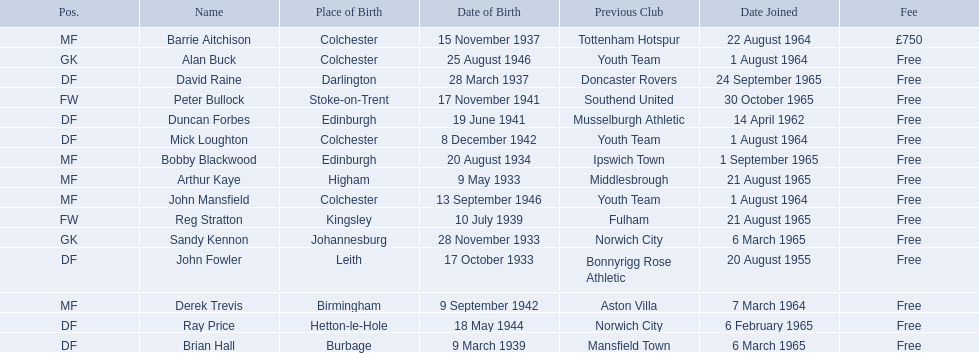When did each player join? 1 August 1964, 6 March 1965, 14 April 1962, 20 August 1955, 6 March 1965, 1 August 1964, 6 February 1965, 24 September 1965, 22 August 1964, 1 September 1965, 21 August 1965, 1 August 1964, 7 March 1964, 30 October 1965, 21 August 1965. And of those, which is the earliest join date? 20 August 1955. Parse the table in full. {'header': ['Pos.', 'Name', 'Place of Birth', 'Date of Birth', 'Previous Club', 'Date Joined', 'Fee'], 'rows': [['MF', 'Barrie Aitchison', 'Colchester', '15 November 1937', 'Tottenham Hotspur', '22 August 1964', '£750'], ['GK', 'Alan Buck', 'Colchester', '25 August 1946', 'Youth Team', '1 August 1964', 'Free'], ['DF', 'David Raine', 'Darlington', '28 March 1937', 'Doncaster Rovers', '24 September 1965', 'Free'], ['FW', 'Peter Bullock', 'Stoke-on-Trent', '17 November 1941', 'Southend United', '30 October 1965', 'Free'], ['DF', 'Duncan Forbes', 'Edinburgh', '19 June 1941', 'Musselburgh Athletic', '14 April 1962', 'Free'], ['DF', 'Mick Loughton', 'Colchester', '8 December 1942', 'Youth Team', '1 August 1964', 'Free'], ['MF', 'Bobby Blackwood', 'Edinburgh', '20 August 1934', 'Ipswich Town', '1 September 1965', 'Free'], ['MF', 'Arthur Kaye', 'Higham', '9 May 1933', 'Middlesbrough', '21 August 1965', 'Free'], ['MF', 'John Mansfield', 'Colchester', '13 September 1946', 'Youth Team', '1 August 1964', 'Free'], ['FW', 'Reg Stratton', 'Kingsley', '10 July 1939', 'Fulham', '21 August 1965', 'Free'], ['GK', 'Sandy Kennon', 'Johannesburg', '28 November 1933', 'Norwich City', '6 March 1965', 'Free'], ['DF', 'John Fowler', 'Leith', '17 October 1933', 'Bonnyrigg Rose Athletic', '20 August 1955', 'Free'], ['MF', 'Derek Trevis', 'Birmingham', '9 September 1942', 'Aston Villa', '7 March 1964', 'Free'], ['DF', 'Ray Price', 'Hetton-le-Hole', '18 May 1944', 'Norwich City', '6 February 1965', 'Free'], ['DF', 'Brian Hall', 'Burbage', '9 March 1939', 'Mansfield Town', '6 March 1965', 'Free']]} 